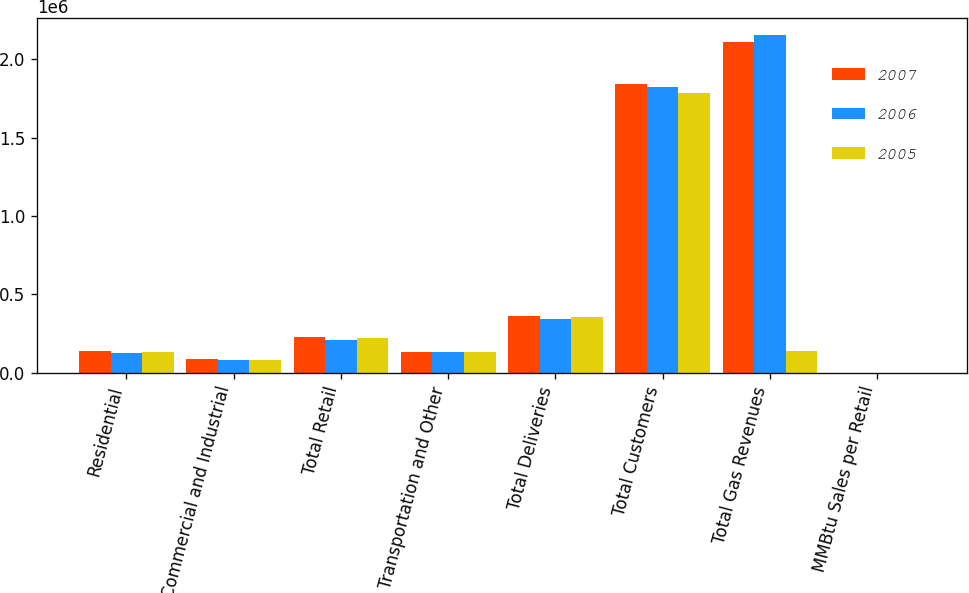Convert chart to OTSL. <chart><loc_0><loc_0><loc_500><loc_500><stacked_bar_chart><ecel><fcel>Residential<fcel>Commercial and Industrial<fcel>Total Retail<fcel>Transportation and Other<fcel>Total Deliveries<fcel>Total Customers<fcel>Total Gas Revenues<fcel>MMBtu Sales per Retail<nl><fcel>2007<fcel>138198<fcel>88668<fcel>226866<fcel>133851<fcel>360717<fcel>1.8427e+06<fcel>2.11173e+06<fcel>123.39<nl><fcel>2006<fcel>126846<fcel>81107<fcel>207953<fcel>135708<fcel>343661<fcel>1.82134e+06<fcel>2.156e+06<fcel>114.43<nl><fcel>2005<fcel>135794<fcel>83667<fcel>219461<fcel>134061<fcel>353522<fcel>1.78548e+06<fcel>138198<fcel>123.17<nl></chart> 